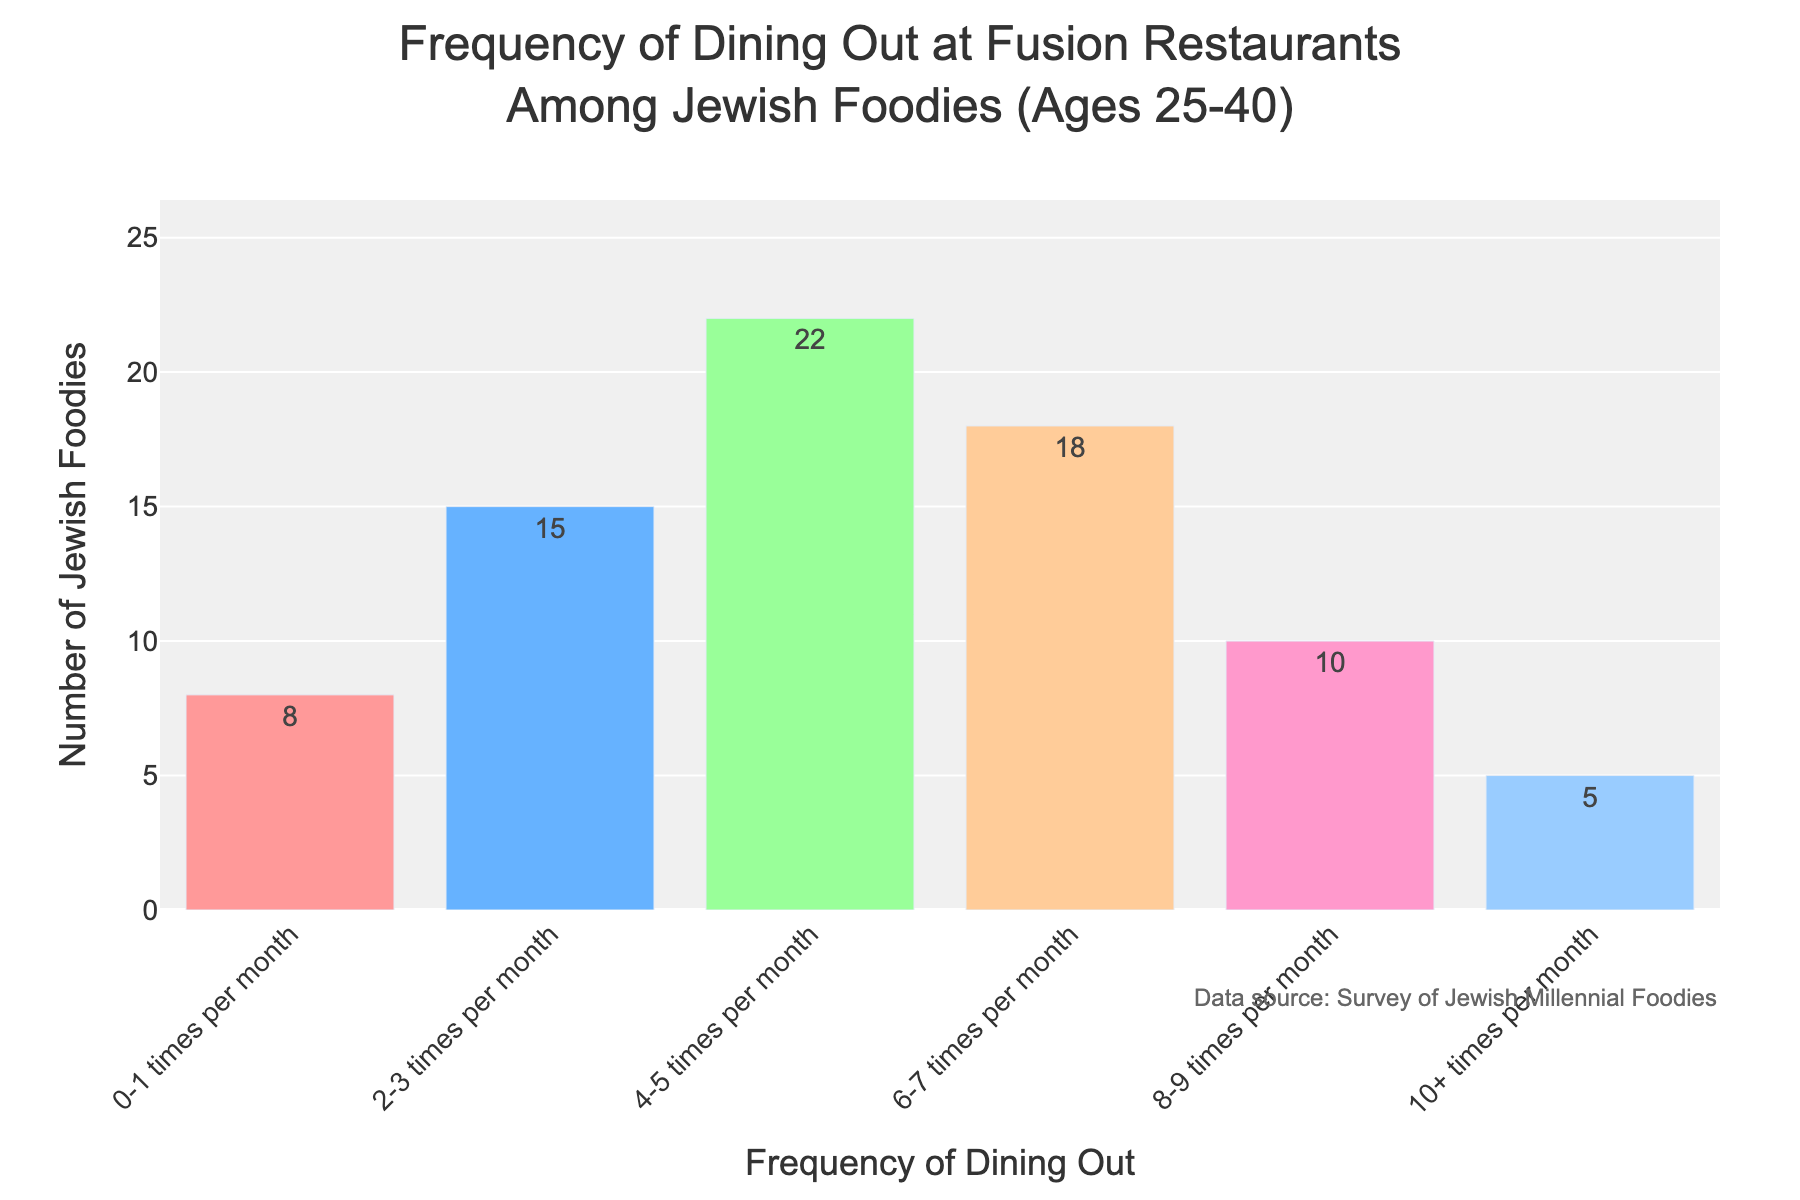what is the title of the histogram? The title is displayed at the top of the plot. It reads "Frequency of Dining Out at Fusion Restaurants Among Jewish Foodies (Ages 25-40)".
Answer: Frequency of Dining Out at Fusion Restaurants Among Jewish Foodies (Ages 25-40) What is the range of frequencies displayed on the x-axis? The x-axis lists the different ranges of dining out frequencies. These are: 0-1 times per month, 2-3 times per month, 4-5 times per month, 6-7 times per month, 8-9 times per month, and 10+ times per month.
Answer: 0-1, 2-3, 4-5, 6-7, 8-9, 10+ times per month Which frequency range has the highest number of Jewish foodies? By comparing the heights of the bars, the highest one represents the 4-5 times per month frequency, with a count of 22 Jewish foodies.
Answer: 4-5 times per month How many Jewish foodies dine out at fusion restaurants 2-3 times per month? The bar corresponding to the 2-3 times per month frequency shows a value of 15, which indicates the number of Jewish foodies dining out this often.
Answer: 15 Calculate the total number of Jewish foodies who dine out at fusion restaurants at least 6 times per month. To find this, sum the values for the 6-7 times per month, 8-9 times per month, and 10+ times per month categories: 18 + 10 + 5 = 33.
Answer: 33 Which two frequency ranges have the closest number of Jewish foodies? By comparing the values, the closest are 8-9 times per month (10 foodies) and 10+ times per month (5 foodies), with a difference of 5.
Answer: 8-9 times and 10+ times per month What is the difference in the number of Jewish foodies between the 6-7 times per month and 0-1 times per month categories? Subtract the number of foodies in the 0-1 times per month category (8) from those in the 6-7 times per month category (18): 18 - 8 = 10.
Answer: 10 Rank the frequency ranges from highest to lowest based on the number of Jewish foodies. The number of Jewish foodies in descending order is: 4-5 times per month (22), 6-7 times per month (18), 2-3 times per month (15), 8-9 times per month (10), 0-1 times per month (8), 10+ times per month (5).
Answer: 4-5, 6-7, 2-3, 8-9, 0-1, 10+ times What proportion of Jewish foodies dine out 0-1 times per month? Calculate the total number of foodies first: 8 + 15 + 22 + 18 + 10 + 5 = 78. The proportion for 0-1 times per month is 8 out of 78, which simplifies to 8/78 ≈ 0.1026 or 10.26%.
Answer: 10.26% 